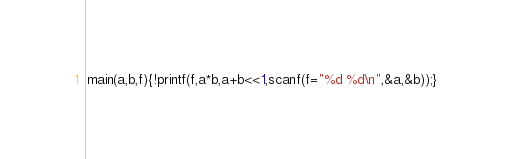Convert code to text. <code><loc_0><loc_0><loc_500><loc_500><_C_>main(a,b,f){!printf(f,a*b,a+b<<1,scanf(f="%d %d\n",&a,&b));}</code> 